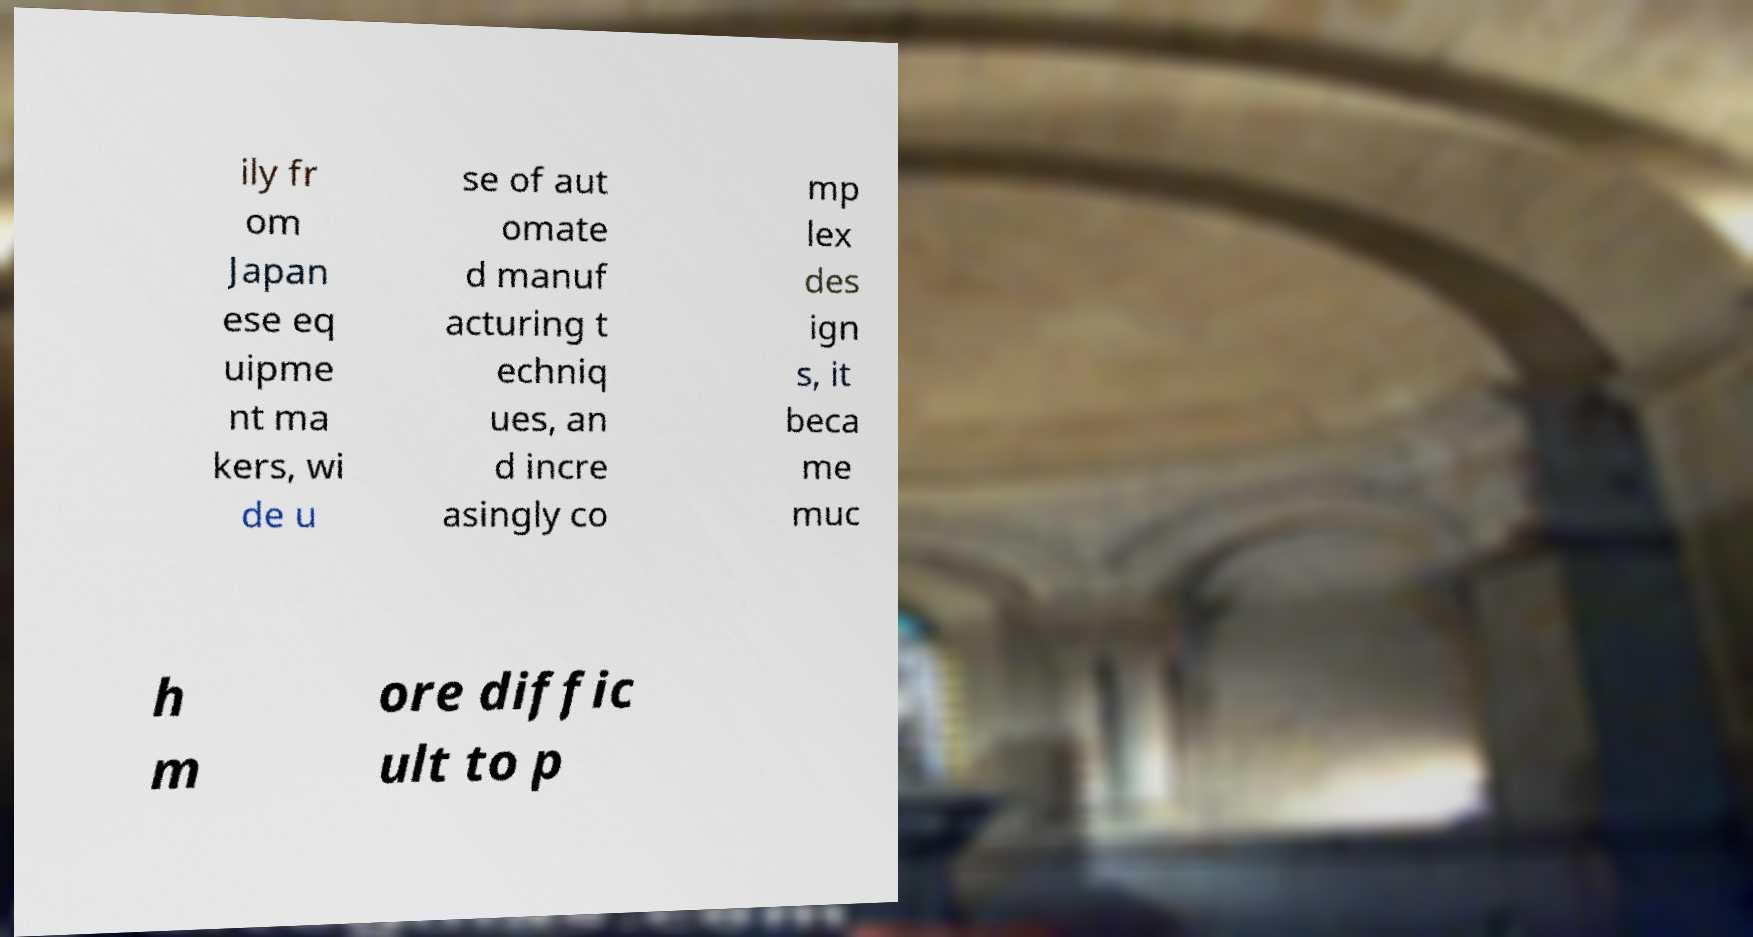I need the written content from this picture converted into text. Can you do that? ily fr om Japan ese eq uipme nt ma kers, wi de u se of aut omate d manuf acturing t echniq ues, an d incre asingly co mp lex des ign s, it beca me muc h m ore diffic ult to p 